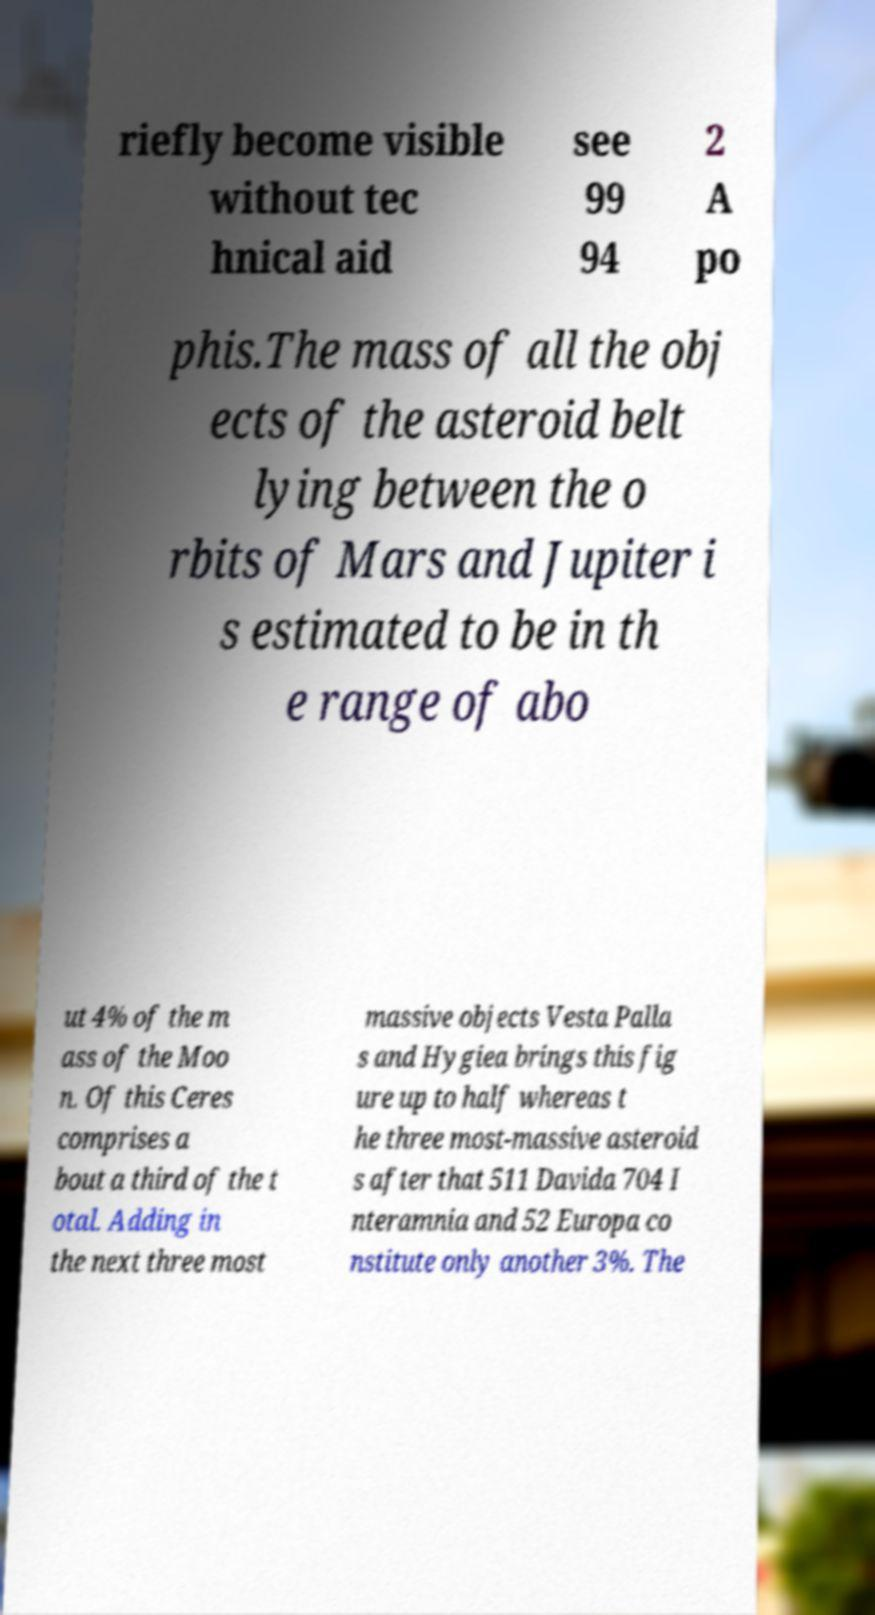Could you assist in decoding the text presented in this image and type it out clearly? riefly become visible without tec hnical aid see 99 94 2 A po phis.The mass of all the obj ects of the asteroid belt lying between the o rbits of Mars and Jupiter i s estimated to be in th e range of abo ut 4% of the m ass of the Moo n. Of this Ceres comprises a bout a third of the t otal. Adding in the next three most massive objects Vesta Palla s and Hygiea brings this fig ure up to half whereas t he three most-massive asteroid s after that 511 Davida 704 I nteramnia and 52 Europa co nstitute only another 3%. The 